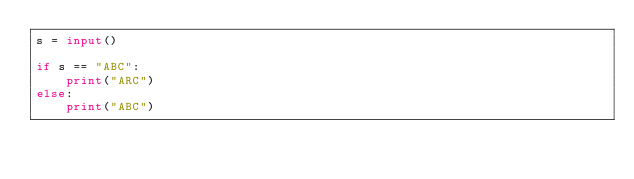<code> <loc_0><loc_0><loc_500><loc_500><_Python_>s = input()

if s == "ABC":
    print("ARC")
else:
    print("ABC")</code> 